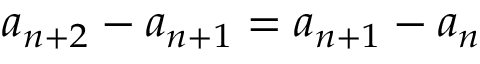<formula> <loc_0><loc_0><loc_500><loc_500>a _ { n + 2 } - a _ { n + 1 } = a _ { n + 1 } - a _ { n }</formula> 